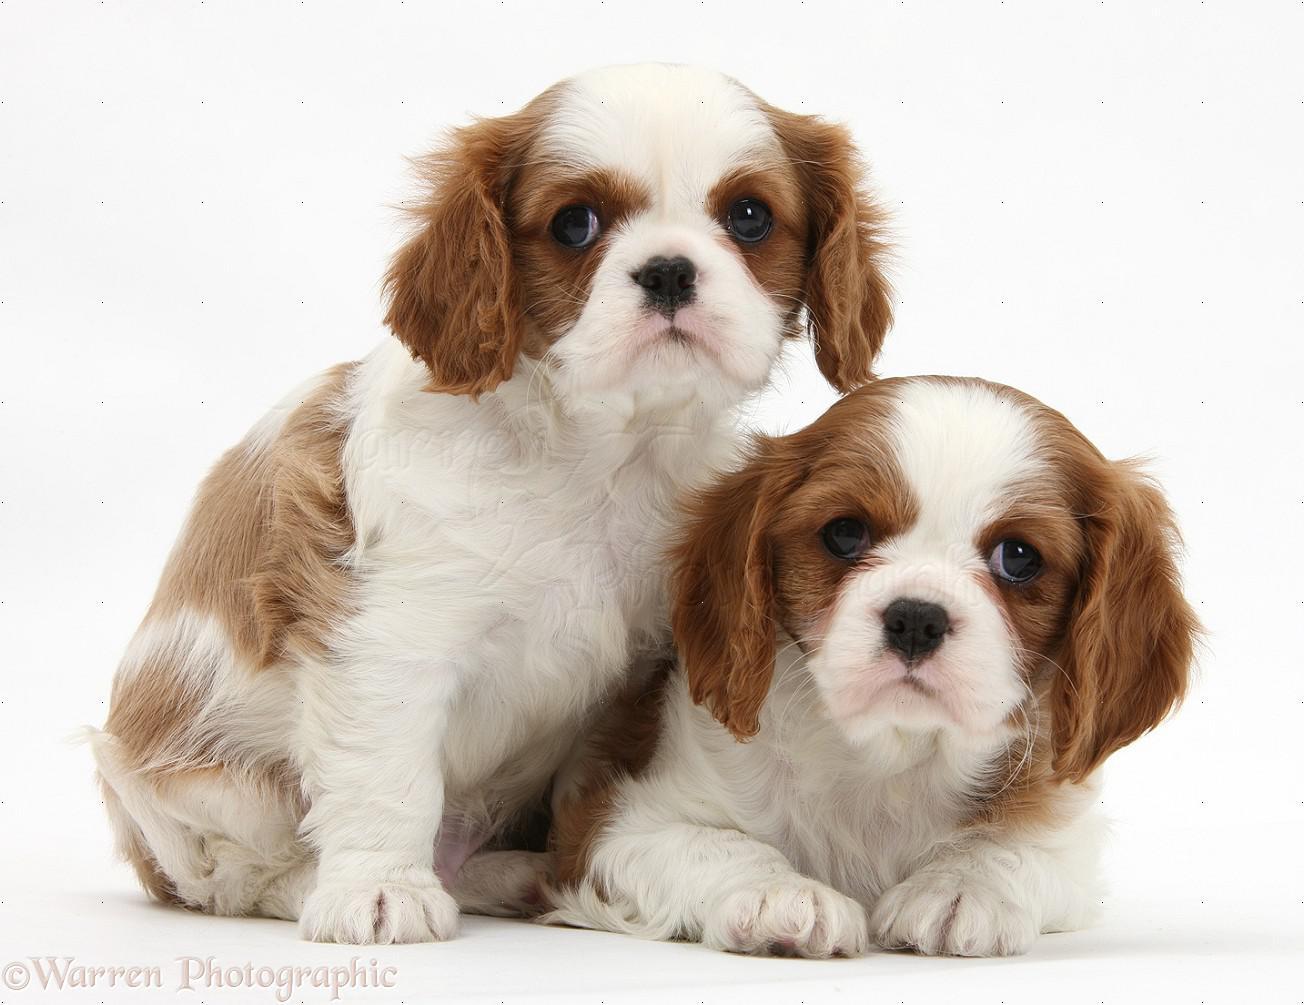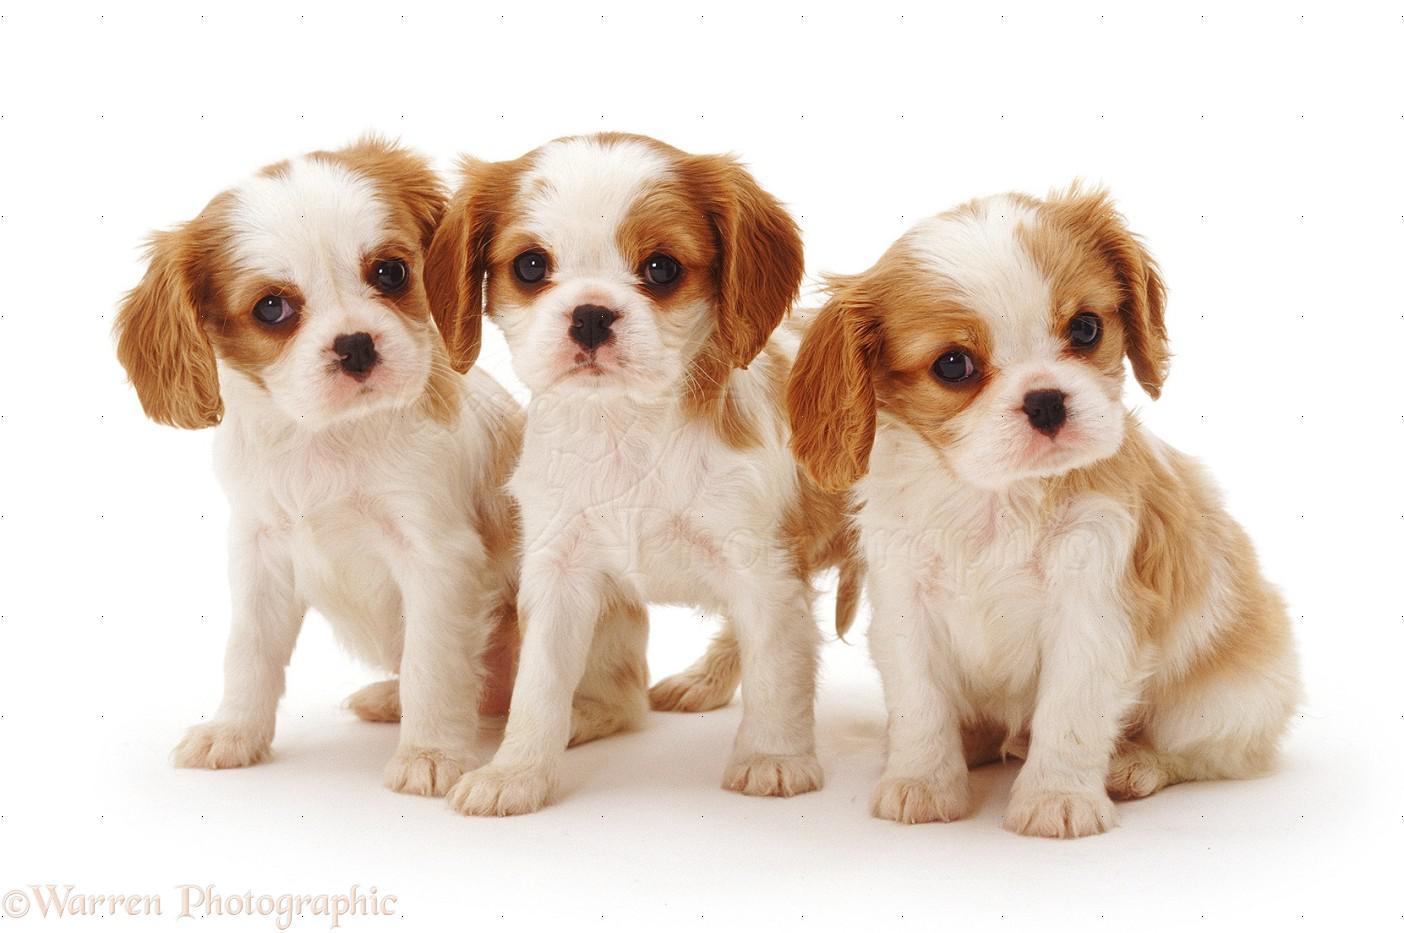The first image is the image on the left, the second image is the image on the right. Assess this claim about the two images: "There are a total of exactly four dogs.". Correct or not? Answer yes or no. No. 